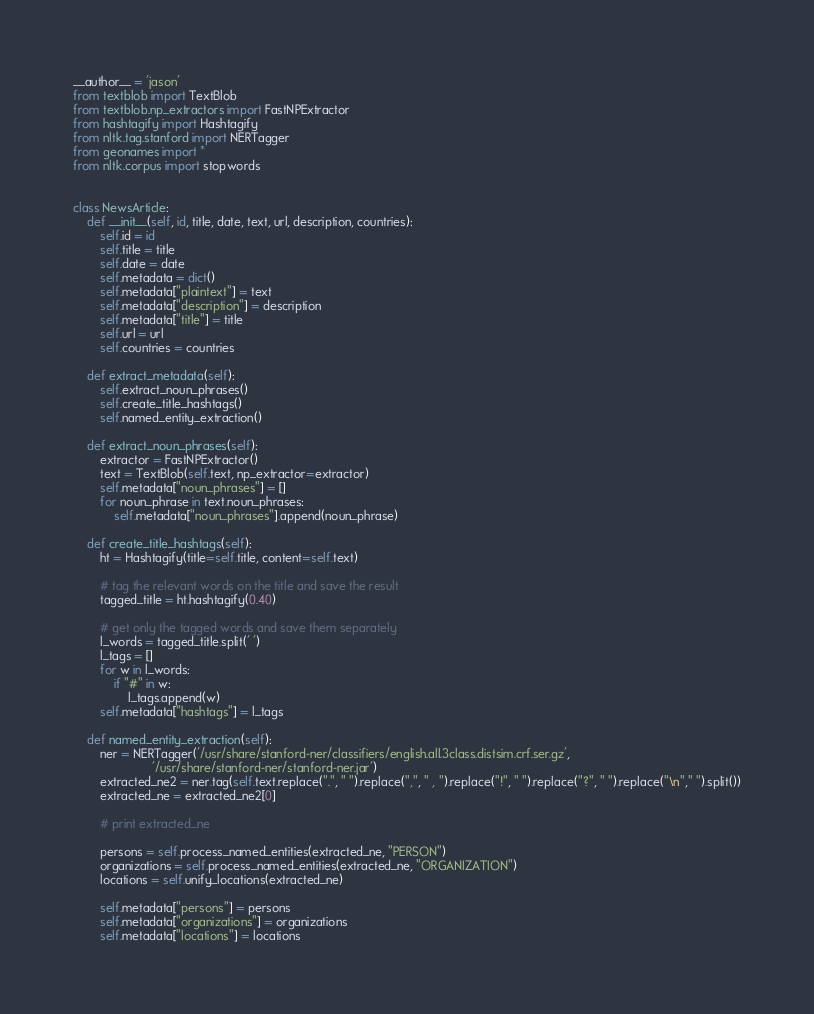<code> <loc_0><loc_0><loc_500><loc_500><_Python_>__author__ = 'jason'
from textblob import TextBlob
from textblob.np_extractors import FastNPExtractor
from hashtagify import Hashtagify
from nltk.tag.stanford import NERTagger
from geonames import *
from nltk.corpus import stopwords


class NewsArticle:
    def __init__(self, id, title, date, text, url, description, countries):
        self.id = id
        self.title = title
        self.date = date
        self.metadata = dict()
        self.metadata["plaintext"] = text
        self.metadata["description"] = description
        self.metadata["title"] = title
        self.url = url
        self.countries = countries

    def extract_metadata(self):
        self.extract_noun_phrases()
        self.create_title_hashtags()
        self.named_entity_extraction()

    def extract_noun_phrases(self):
        extractor = FastNPExtractor()
        text = TextBlob(self.text, np_extractor=extractor)
        self.metadata["noun_phrases"] = []
        for noun_phrase in text.noun_phrases:
            self.metadata["noun_phrases"].append(noun_phrase)

    def create_title_hashtags(self):
        ht = Hashtagify(title=self.title, content=self.text)

        # tag the relevant words on the title and save the result
        tagged_title = ht.hashtagify(0.40)

        # get only the tagged words and save them separately
        l_words = tagged_title.split(' ')
        l_tags = []
        for w in l_words:
            if "#" in w:
                l_tags.append(w)
        self.metadata["hashtags"] = l_tags

    def named_entity_extraction(self):
        ner = NERTagger('/usr/share/stanford-ner/classifiers/english.all.3class.distsim.crf.ser.gz',
                       '/usr/share/stanford-ner/stanford-ner.jar')
        extracted_ne2 = ner.tag(self.text.replace(".", " ").replace(",", " , ").replace("!", " ").replace("?", " ").replace("\n"," ").split())
        extracted_ne = extracted_ne2[0]
        
        # print extracted_ne
        
        persons = self.process_named_entities(extracted_ne, "PERSON")
        organizations = self.process_named_entities(extracted_ne, "ORGANIZATION")
        locations = self.unify_locations(extracted_ne)
        
        self.metadata["persons"] = persons
        self.metadata["organizations"] = organizations
        self.metadata["locations"] = locations
</code> 